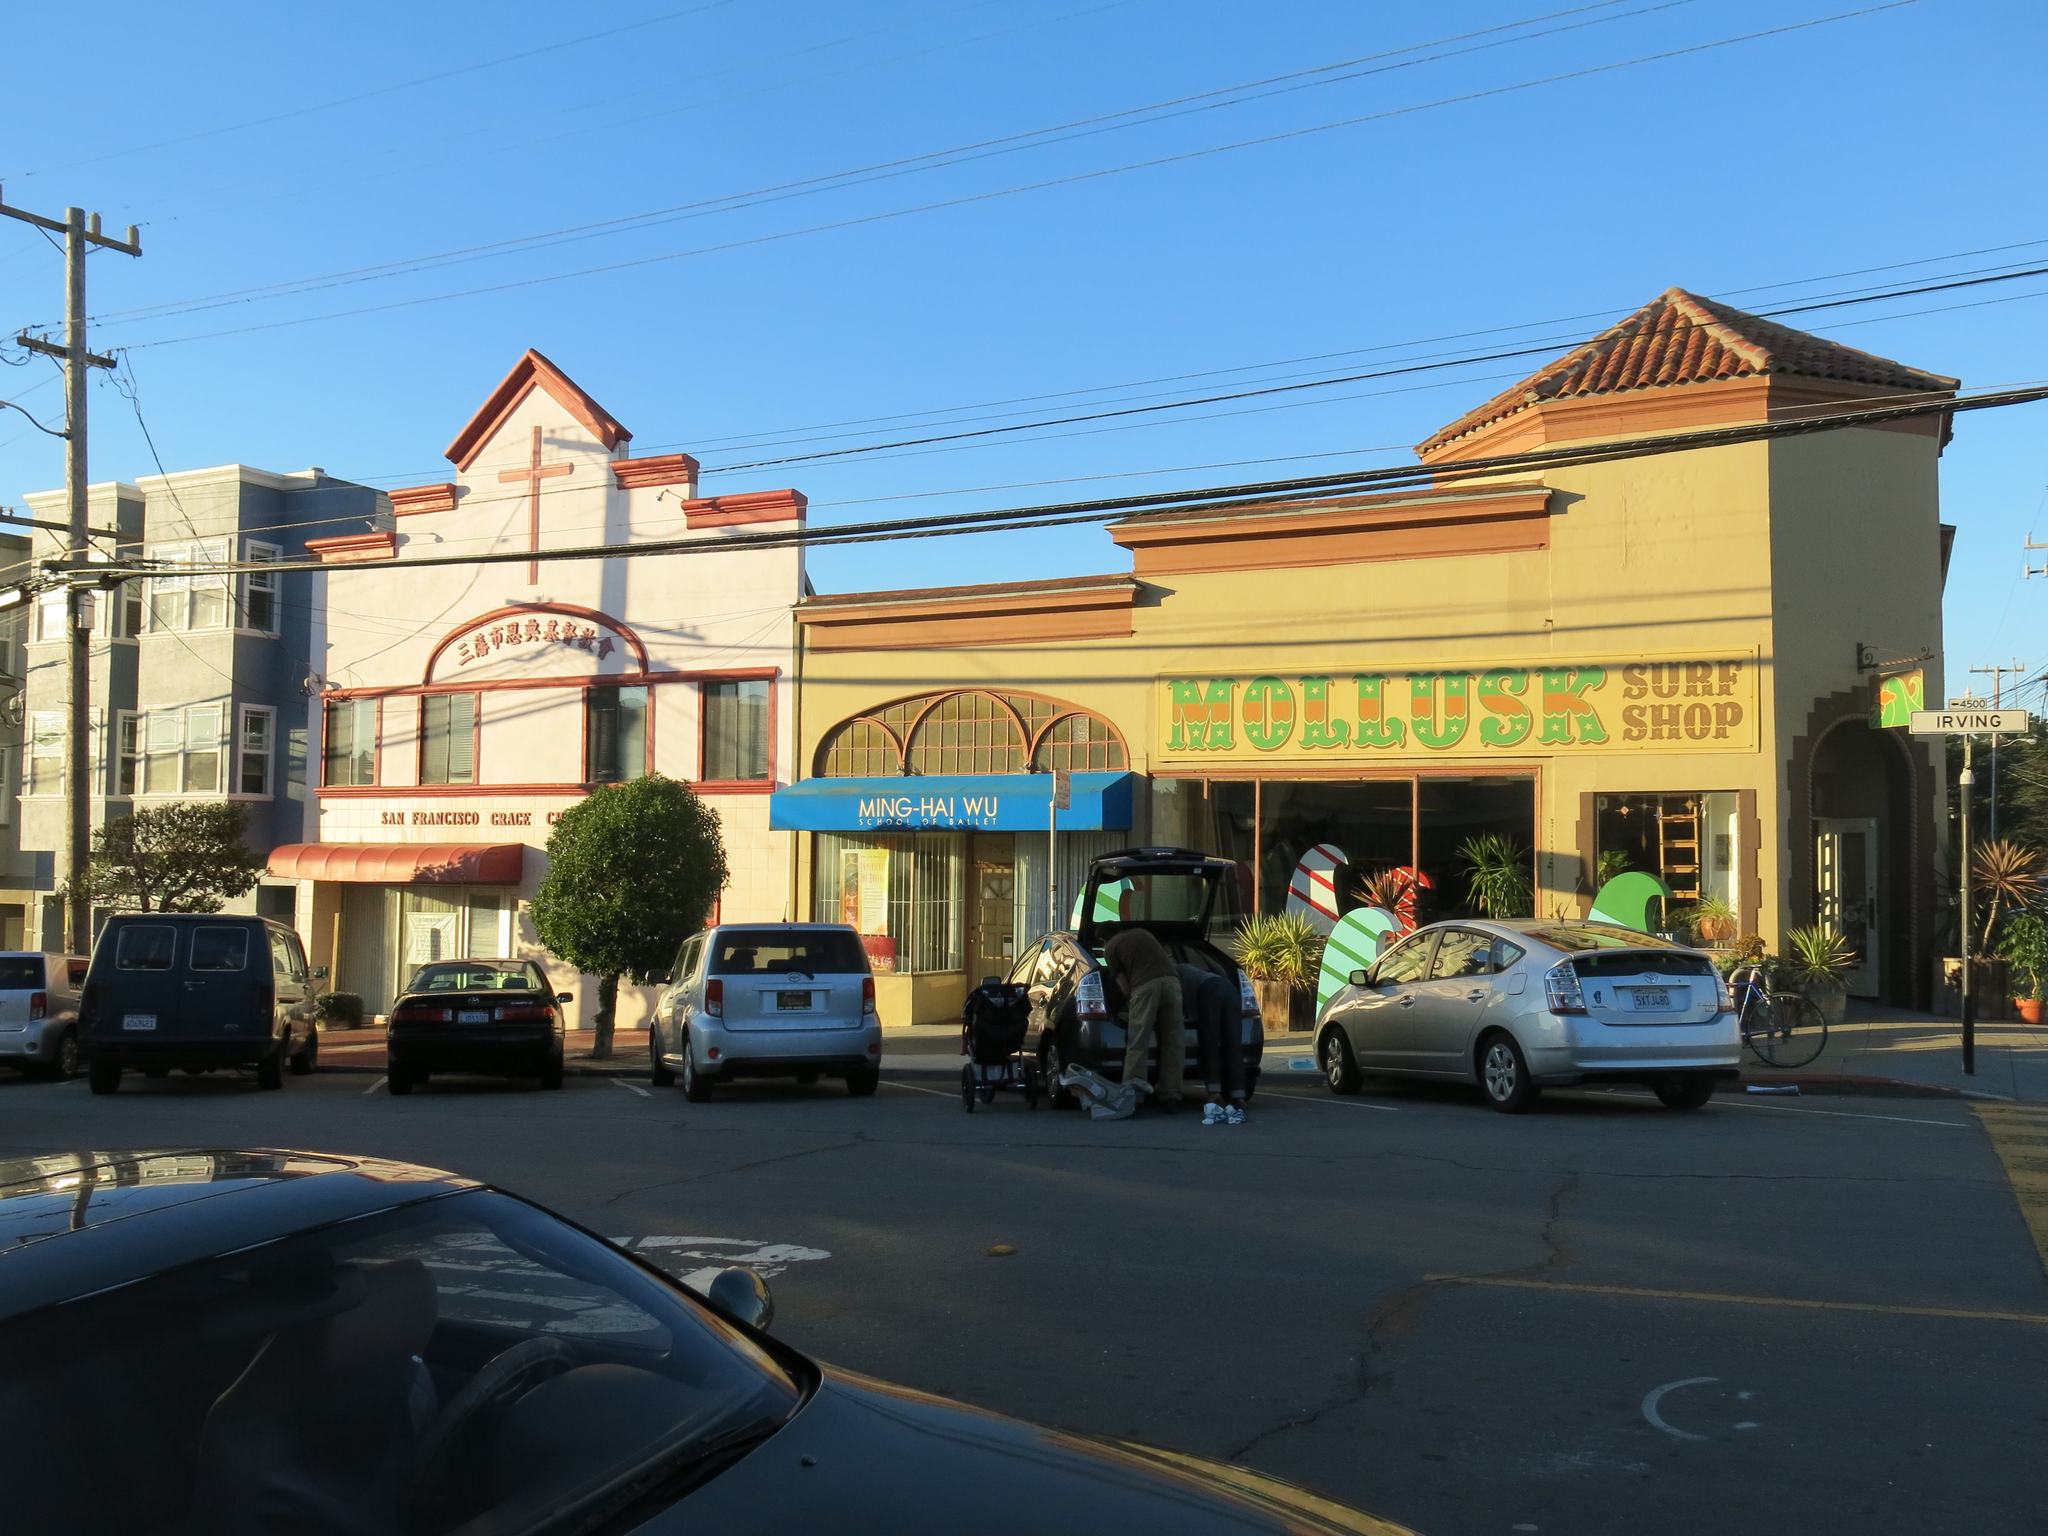Could you give a brief overview of what you see in this image? In this picture there are few buildings which has few plants and vehicles parked in front of it and there is a pole which has few wires attached to it and a car in the left corner. 